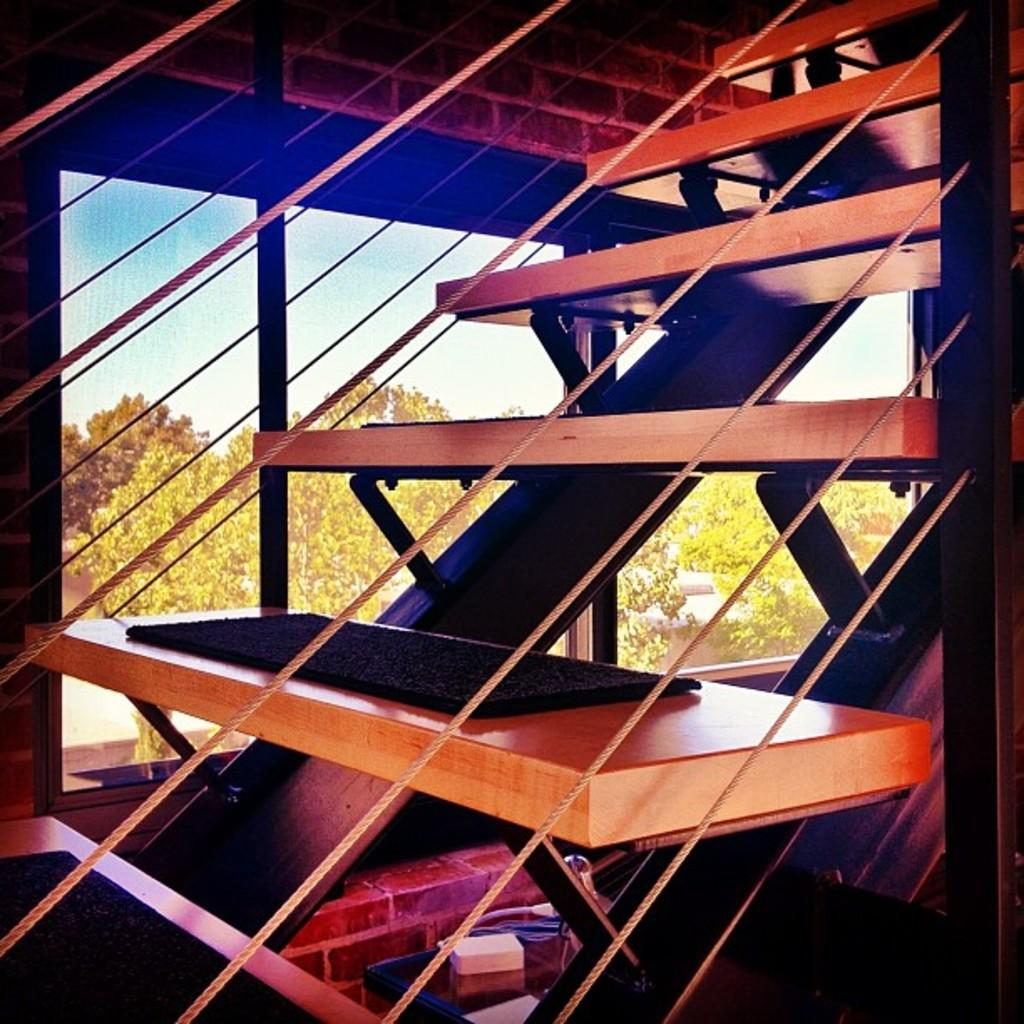What type of architectural feature is present in the image? There is a staircase in the image. What else can be seen in the image besides the staircase? There are objects, windows, and a wall visible in the image. What is visible through the windows in the image? Trees and clouds are visible through the window glasses in the image. How many sisters are holding hands in the image? There are no sisters present in the image. What type of magic is being performed in the image? There is no magic or any magical elements present in the image. 